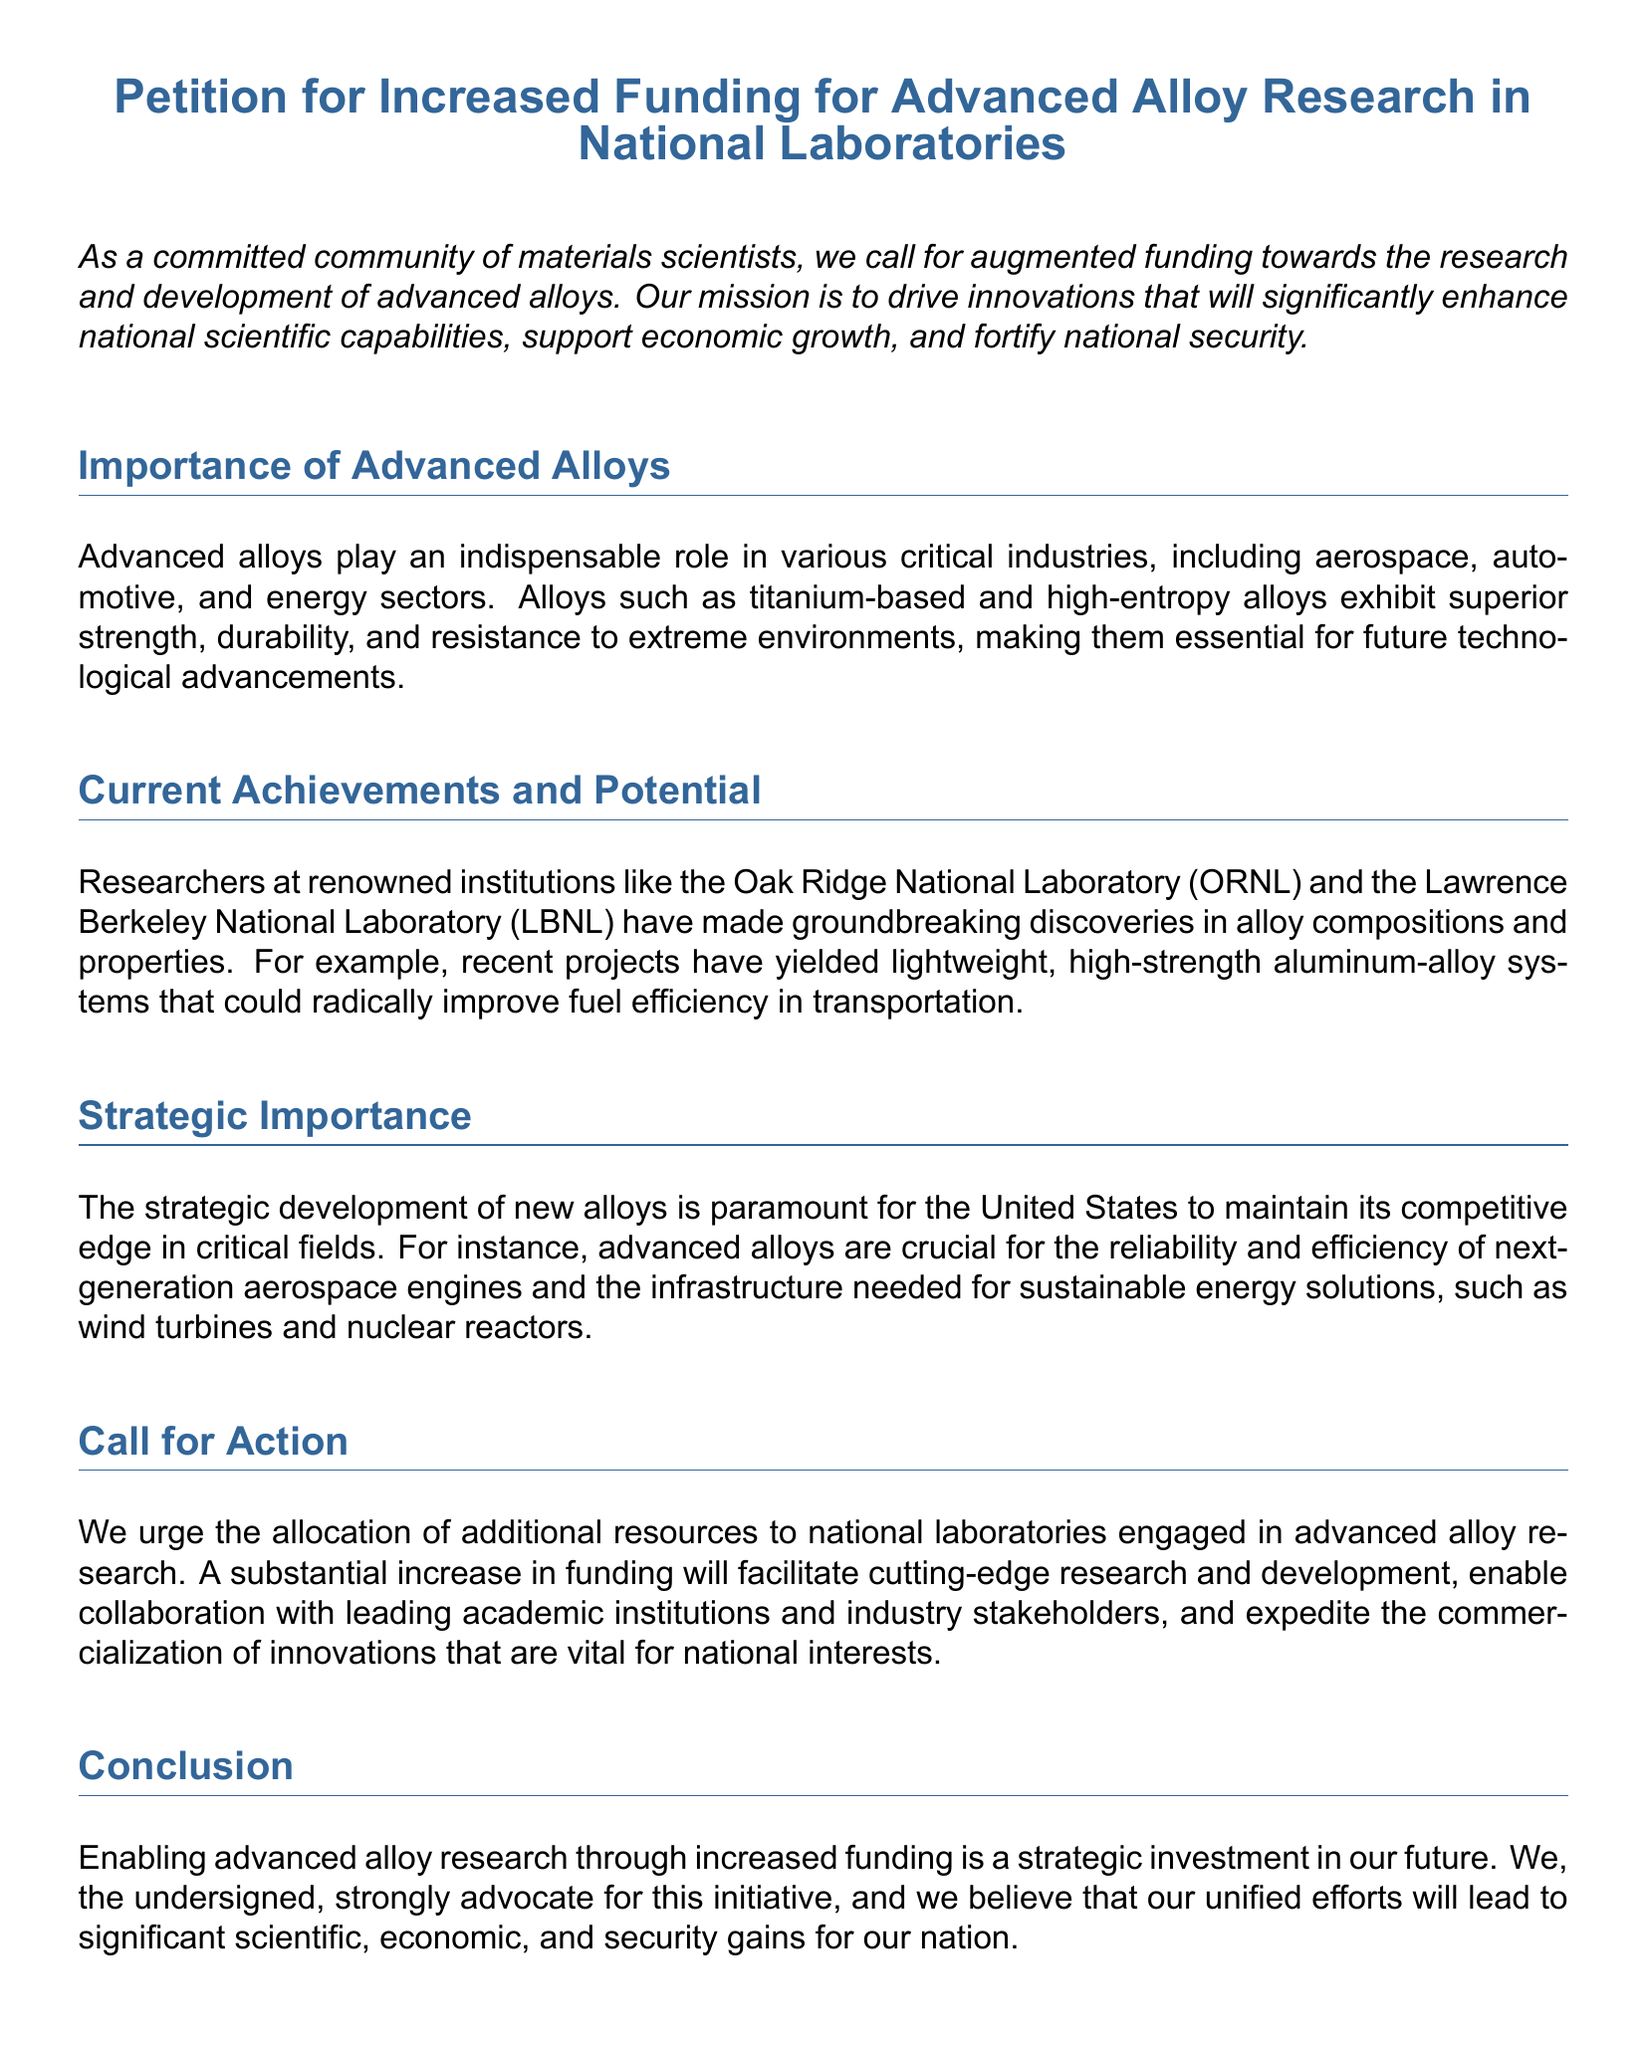What is the title of the petition? The title of the petition is stated at the beginning of the document.
Answer: Petition for Increased Funding for Advanced Alloy Research in National Laboratories Who are the researchers mentioned in the petition? The petition lists several researchers as signatories, including their names and titles.
Answer: Dr. Alex Morgan, Dr. Emily Chen, Dr. John Doe, Dr. Sarah Lee What are advanced alloys important for? The document mentions several industries where advanced alloys are critical.
Answer: Aerospace, automotive, energy sectors Which laboratory is mentioned in association with lightweight aluminum-alloy systems? The document lists specific national laboratories that are involved in alloy research.
Answer: Oak Ridge National Laboratory What does the petition urge regarding funding? The document clearly states a specific action it is calling for concerning funding.
Answer: Allocation of additional resources How many significant researchers signed the petition? The document specifies the number of researchers listed as signatories.
Answer: Four What strategic benefit does the document attribute to advanced alloys? The petition discusses a key benefit of advanced alloys related to national interests.
Answer: Competitive edge What type of document is this? The structure and purpose of the document indicate its classification.
Answer: Petition 